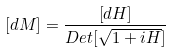Convert formula to latex. <formula><loc_0><loc_0><loc_500><loc_500>[ d M ] = \frac { [ d H ] } { D e t [ \sqrt { 1 + i H } ] }</formula> 